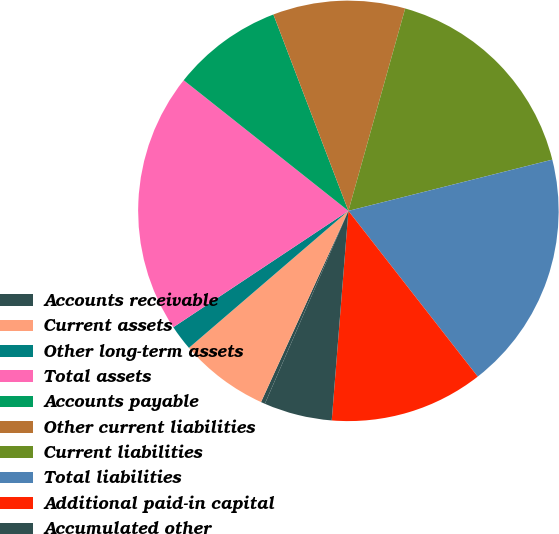Convert chart to OTSL. <chart><loc_0><loc_0><loc_500><loc_500><pie_chart><fcel>Accounts receivable<fcel>Current assets<fcel>Other long-term assets<fcel>Total assets<fcel>Accounts payable<fcel>Other current liabilities<fcel>Current liabilities<fcel>Total liabilities<fcel>Additional paid-in capital<fcel>Accumulated other<nl><fcel>0.32%<fcel>6.88%<fcel>1.96%<fcel>20.01%<fcel>8.52%<fcel>10.16%<fcel>16.73%<fcel>18.37%<fcel>11.81%<fcel>5.24%<nl></chart> 